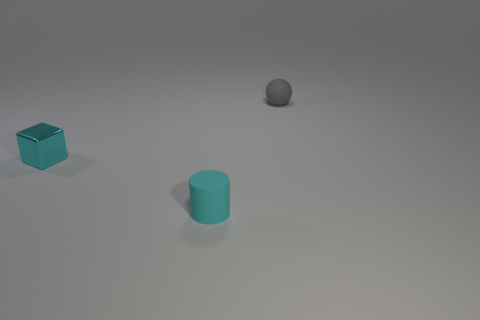There is a small shiny thing that is the same color as the matte cylinder; what shape is it?
Offer a terse response. Cube. Is there a ball that has the same color as the tiny cube?
Offer a very short reply. No. How big is the sphere?
Provide a short and direct response. Small. Is the material of the cyan cube the same as the gray object?
Make the answer very short. No. There is a rubber thing left of the object that is behind the small cube; how many small cyan rubber things are in front of it?
Ensure brevity in your answer.  0. There is a tiny object behind the small block; what shape is it?
Offer a very short reply. Sphere. What number of other objects are there of the same material as the gray thing?
Offer a very short reply. 1. Does the cube have the same color as the ball?
Your response must be concise. No. Is the number of tiny balls in front of the ball less than the number of gray rubber spheres in front of the small cyan metal cube?
Provide a succinct answer. No. There is a rubber object that is left of the rubber ball; is its size the same as the small gray matte ball?
Provide a short and direct response. Yes. 